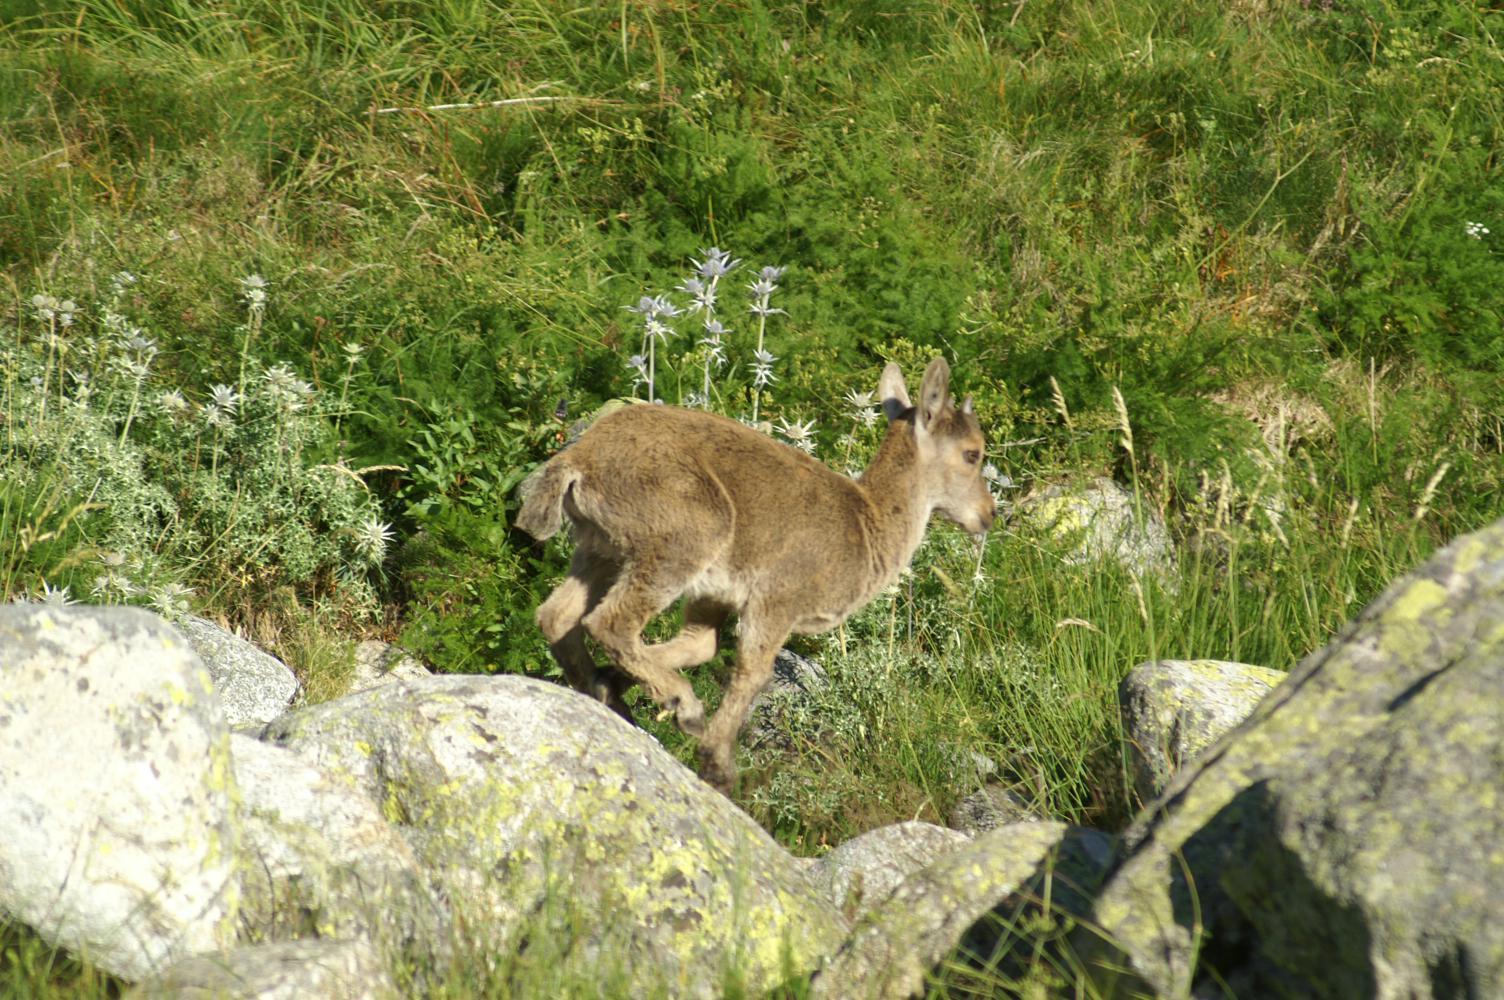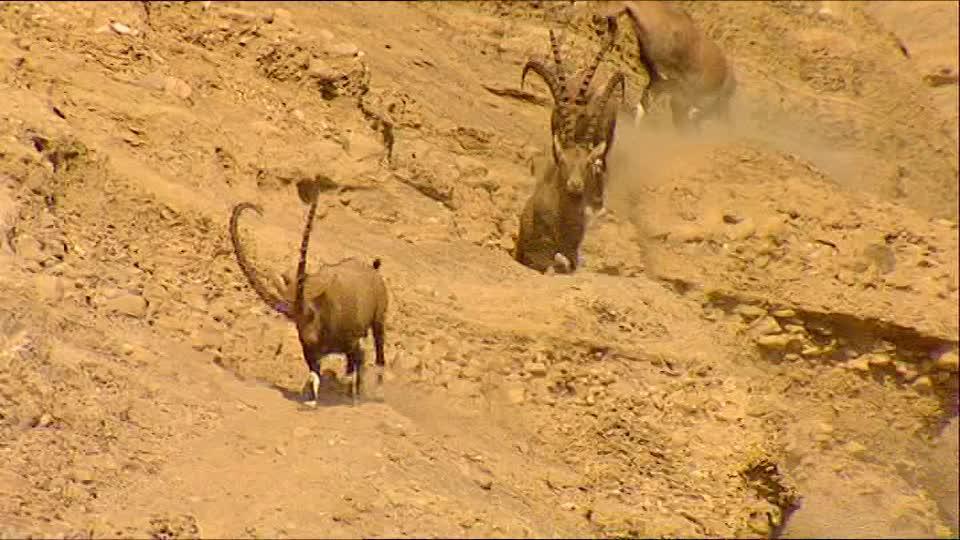The first image is the image on the left, the second image is the image on the right. Analyze the images presented: Is the assertion "There is snow on the ground in the right image." valid? Answer yes or no. No. The first image is the image on the left, the second image is the image on the right. For the images shown, is this caption "One of the images features a mountain goat descending a grassy hill." true? Answer yes or no. Yes. 